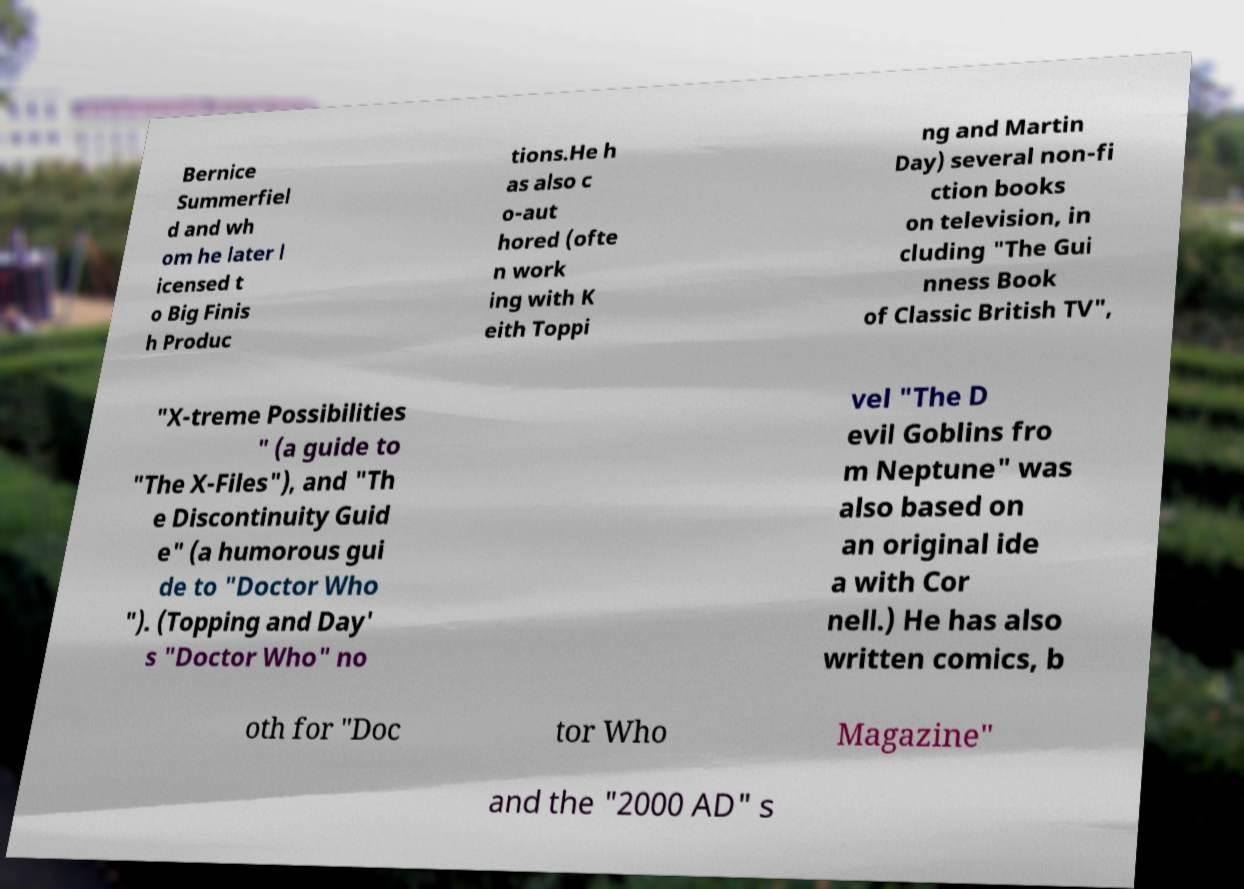Could you extract and type out the text from this image? Bernice Summerfiel d and wh om he later l icensed t o Big Finis h Produc tions.He h as also c o-aut hored (ofte n work ing with K eith Toppi ng and Martin Day) several non-fi ction books on television, in cluding "The Gui nness Book of Classic British TV", "X-treme Possibilities " (a guide to "The X-Files"), and "Th e Discontinuity Guid e" (a humorous gui de to "Doctor Who "). (Topping and Day' s "Doctor Who" no vel "The D evil Goblins fro m Neptune" was also based on an original ide a with Cor nell.) He has also written comics, b oth for "Doc tor Who Magazine" and the "2000 AD" s 